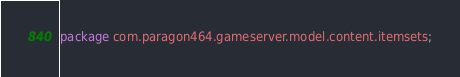<code> <loc_0><loc_0><loc_500><loc_500><_Java_>package com.paragon464.gameserver.model.content.itemsets;
</code> 